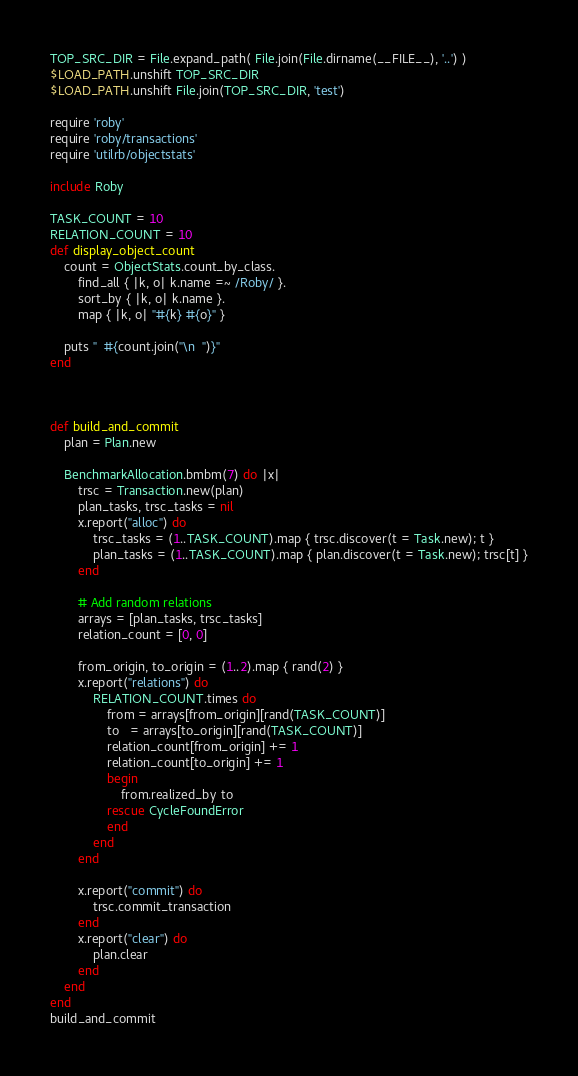<code> <loc_0><loc_0><loc_500><loc_500><_Ruby_>TOP_SRC_DIR = File.expand_path( File.join(File.dirname(__FILE__), '..') )
$LOAD_PATH.unshift TOP_SRC_DIR
$LOAD_PATH.unshift File.join(TOP_SRC_DIR, 'test')

require 'roby'
require 'roby/transactions'
require 'utilrb/objectstats'

include Roby

TASK_COUNT = 10
RELATION_COUNT = 10
def display_object_count
    count = ObjectStats.count_by_class.
        find_all { |k, o| k.name =~ /Roby/ }.
        sort_by { |k, o| k.name }.
        map { |k, o| "#{k} #{o}" }

    puts "  #{count.join("\n  ")}"
end



def build_and_commit
    plan = Plan.new

    BenchmarkAllocation.bmbm(7) do |x|
        trsc = Transaction.new(plan)
        plan_tasks, trsc_tasks = nil
        x.report("alloc") do
            trsc_tasks = (1..TASK_COUNT).map { trsc.discover(t = Task.new); t } 
            plan_tasks = (1..TASK_COUNT).map { plan.discover(t = Task.new); trsc[t] }
        end

        # Add random relations
        arrays = [plan_tasks, trsc_tasks]
        relation_count = [0, 0]

        from_origin, to_origin = (1..2).map { rand(2) }
        x.report("relations") do
            RELATION_COUNT.times do
                from = arrays[from_origin][rand(TASK_COUNT)]
                to   = arrays[to_origin][rand(TASK_COUNT)]
                relation_count[from_origin] += 1
                relation_count[to_origin] += 1
                begin
                    from.realized_by to
                rescue CycleFoundError
                end
            end
        end

        x.report("commit") do
            trsc.commit_transaction
        end
        x.report("clear") do
            plan.clear
        end
    end
end
build_and_commit

</code> 